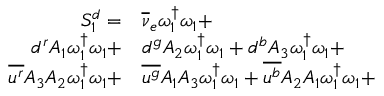<formula> <loc_0><loc_0><loc_500><loc_500>\begin{array} { r l } { S _ { 1 } ^ { d } = } & { \overline { \nu } _ { e } } \omega _ { 1 } ^ { \dagger } \omega _ { 1 } + } \\ { { d } ^ { r } { A _ { 1 } } \omega _ { 1 } ^ { \dagger } \omega _ { 1 } + } & { d } ^ { g } { A _ { 2 } } \omega _ { 1 } ^ { \dagger } \omega _ { 1 } + { d } ^ { b } { A _ { 3 } } \omega _ { 1 } ^ { \dagger } \omega _ { 1 } + } \\ { \overline { { u ^ { r } } } { A _ { 3 } } { A _ { 2 } } \omega _ { 1 } ^ { \dagger } \omega _ { 1 } + } & \overline { { u ^ { g } } } { A _ { 1 } } { A _ { 3 } } \omega _ { 1 } ^ { \dagger } \omega _ { 1 } + \overline { { u ^ { b } } } { A _ { 2 } } { A _ { 1 } } \omega _ { 1 } ^ { \dagger } \omega _ { 1 } + } \end{array}</formula> 